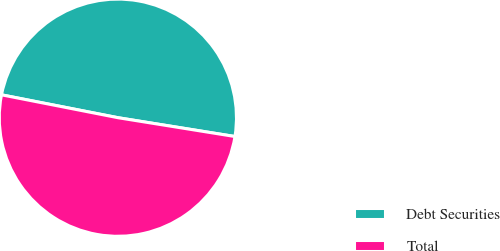Convert chart to OTSL. <chart><loc_0><loc_0><loc_500><loc_500><pie_chart><fcel>Debt Securities<fcel>Total<nl><fcel>49.45%<fcel>50.55%<nl></chart> 